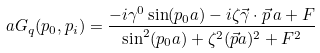<formula> <loc_0><loc_0><loc_500><loc_500>a G _ { q } ( p _ { 0 } , p _ { i } ) = \frac { - i \gamma ^ { 0 } \sin ( p _ { 0 } a ) - i \zeta \vec { \gamma } \cdot \vec { p } \, a + F } { \sin ^ { 2 } ( p _ { 0 } a ) + \zeta ^ { 2 } ( \vec { p } a ) ^ { 2 } + F ^ { 2 } }</formula> 